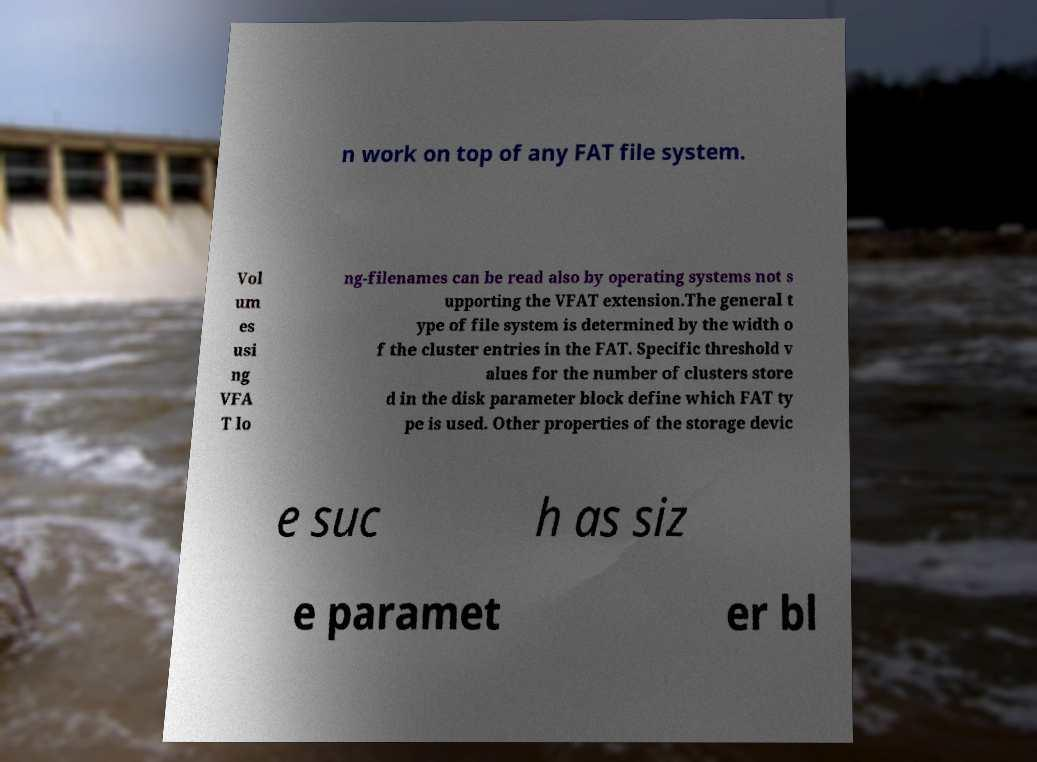Can you read and provide the text displayed in the image?This photo seems to have some interesting text. Can you extract and type it out for me? n work on top of any FAT file system. Vol um es usi ng VFA T lo ng-filenames can be read also by operating systems not s upporting the VFAT extension.The general t ype of file system is determined by the width o f the cluster entries in the FAT. Specific threshold v alues for the number of clusters store d in the disk parameter block define which FAT ty pe is used. Other properties of the storage devic e suc h as siz e paramet er bl 